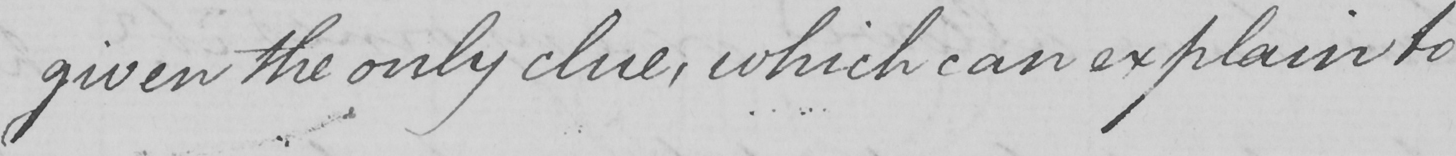Can you read and transcribe this handwriting? given the only clue , which can explain to 